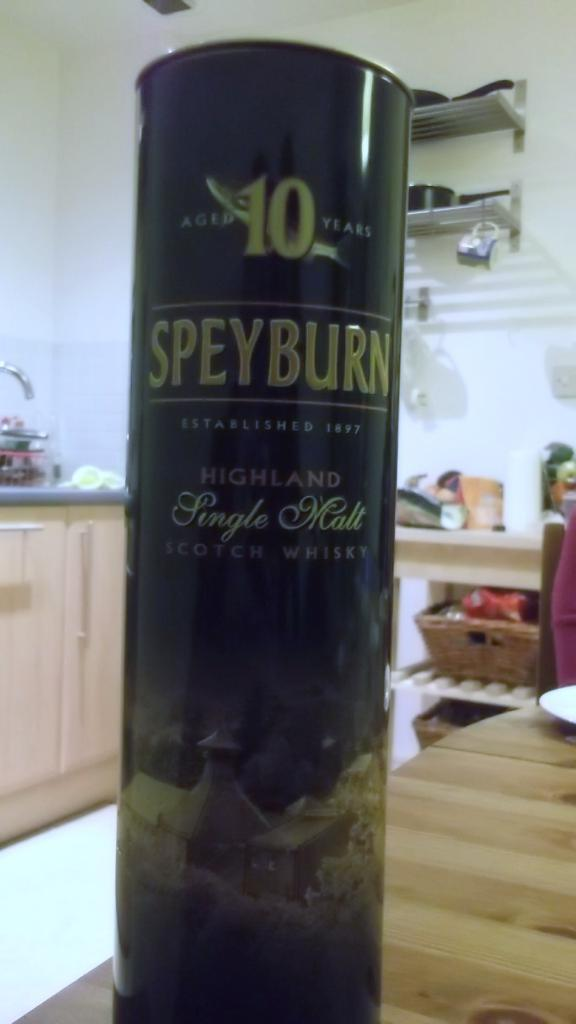<image>
Summarize the visual content of the image. A container of Single Malt Scotch Whisky sits on a kitchen counter. 